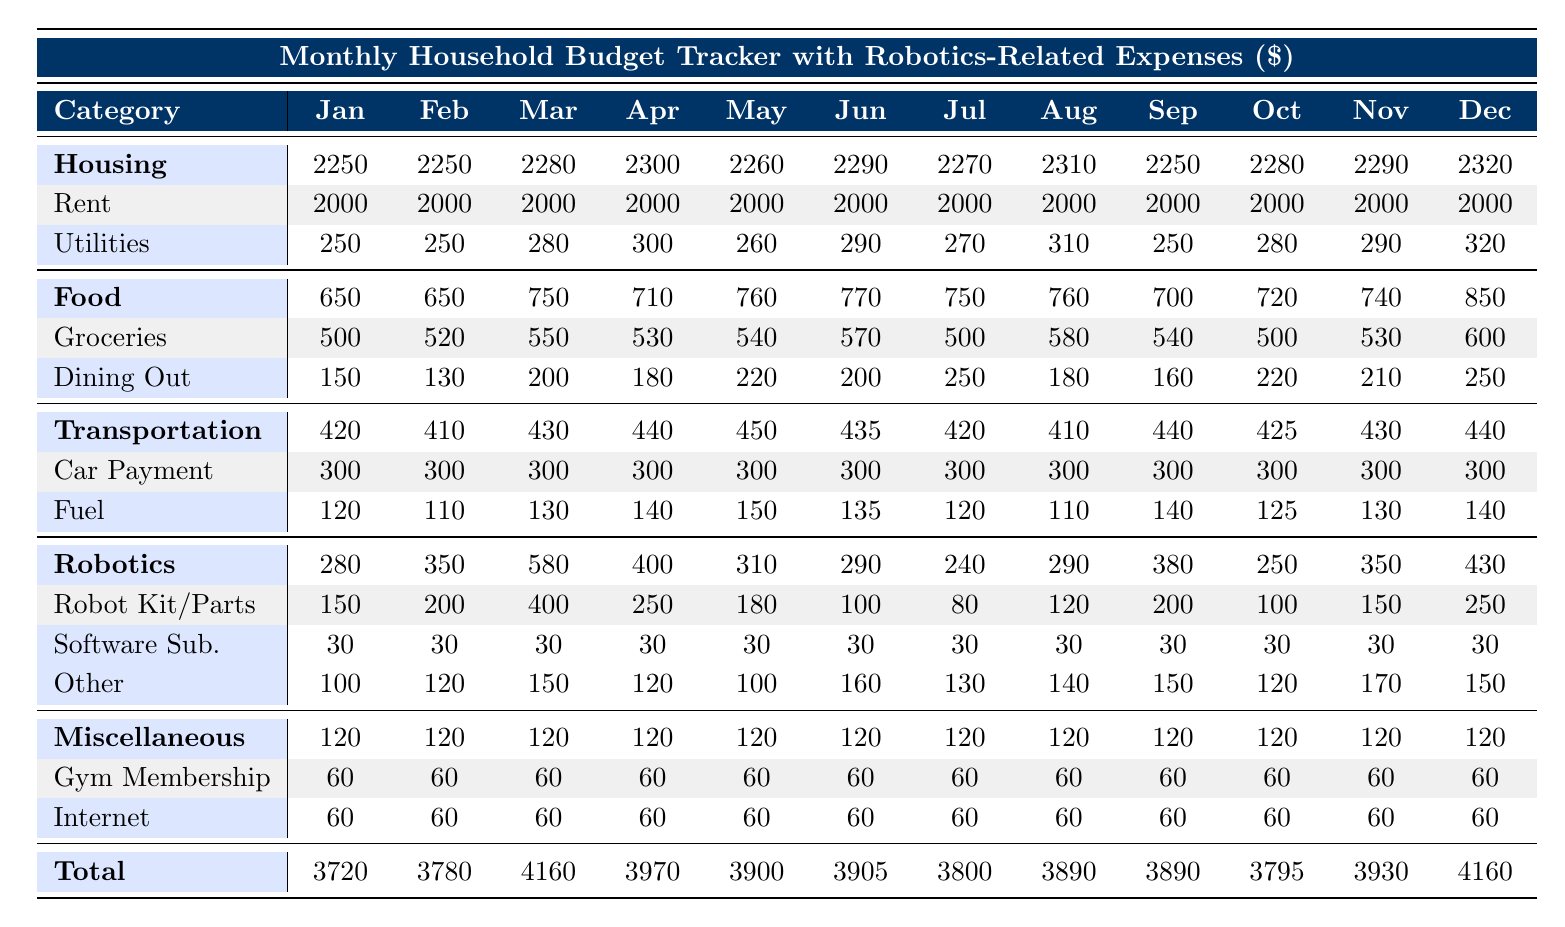What was the total amount spent on housing in June? In June, the total expenditure on housing is the sum of rent and utilities. The rent is $2000 and utilities are $290, so the total is 2000 + 290 = 2290.
Answer: 2290 Which month had the highest Robotics Expenses? To find the month with the highest Robotics Expenses, we look at each month's total under the Robotics Expenses section: January (280), February (350), March (580), April (400), May (310), June (290), July (240), August (290), September (380), October (250), November (350), December (430). April had the highest Robotics Expenses of 580 in March.
Answer: March Is the monthly utility expense ever less than $250? By examining the utilities row for each month, we see the following values: January (250), February (250), March (280), April (300), May (260), June (290), July (270), August (310), September (250), October (280), November (290), December (320). None of them are less than $250 hence the statement is false.
Answer: No What is the average monthly expenditure for food over the 12 months? To calculate the average food expenditure, first sum the monthly total for food: (650 + 650 + 750 + 710 + 760 + 770 + 750 + 760 + 700 + 720 + 740 + 850) = 8280. Then divide by 12 (the number of months) to obtain the average: 8280 / 12 = 690.
Answer: 690 Did the spending on Robotics Expenses decrease from October to November? In October, the total for Robotics Expenses is $250, and in November, it is $350. Since $250 is less than $350, spending did not decrease, it actually increased from October to November.
Answer: No What was the percentage increase in food expenditure from May to June? First, find the food expenditure for May which is $760 and for June which is $770. To find the percentage increase, calculate the difference: (770 - 760) = 10. Then divide that by the original value (760) and multiply by 100: (10 / 760) * 100 = 1.32%.
Answer: 1.32% Which month had the highest total household expenditure? To find the month with the highest total household expenditure, we look at the total row: January (3720), February (3780), March (4160), April (3970), May (3900), June (3905), July (3890), August (3890), September (3795), October (3930), November (3930), December (4160). The highest expenditures occur in March with 4160.
Answer: March Is the Gym Membership expense constant throughout the year? The Gym Membership expense is $60 for each month from January to December, indicating that it remains constant without any changes.
Answer: Yes What was the total spending on Transportation across the whole year? The total spending on Transportation can be obtained by summing each month's transportation expenses: (420 + 410 + 430 + 440 + 450 + 435 + 420 + 410 + 440 + 425 + 430 + 440) = 5230.
Answer: 5230 